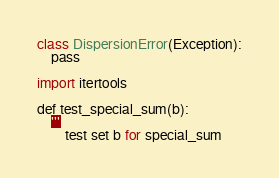<code> <loc_0><loc_0><loc_500><loc_500><_C++_>class DispersionError(Exception):
    pass

import itertools

def test_special_sum(b):
    '''
        test set b for special_sum</code> 